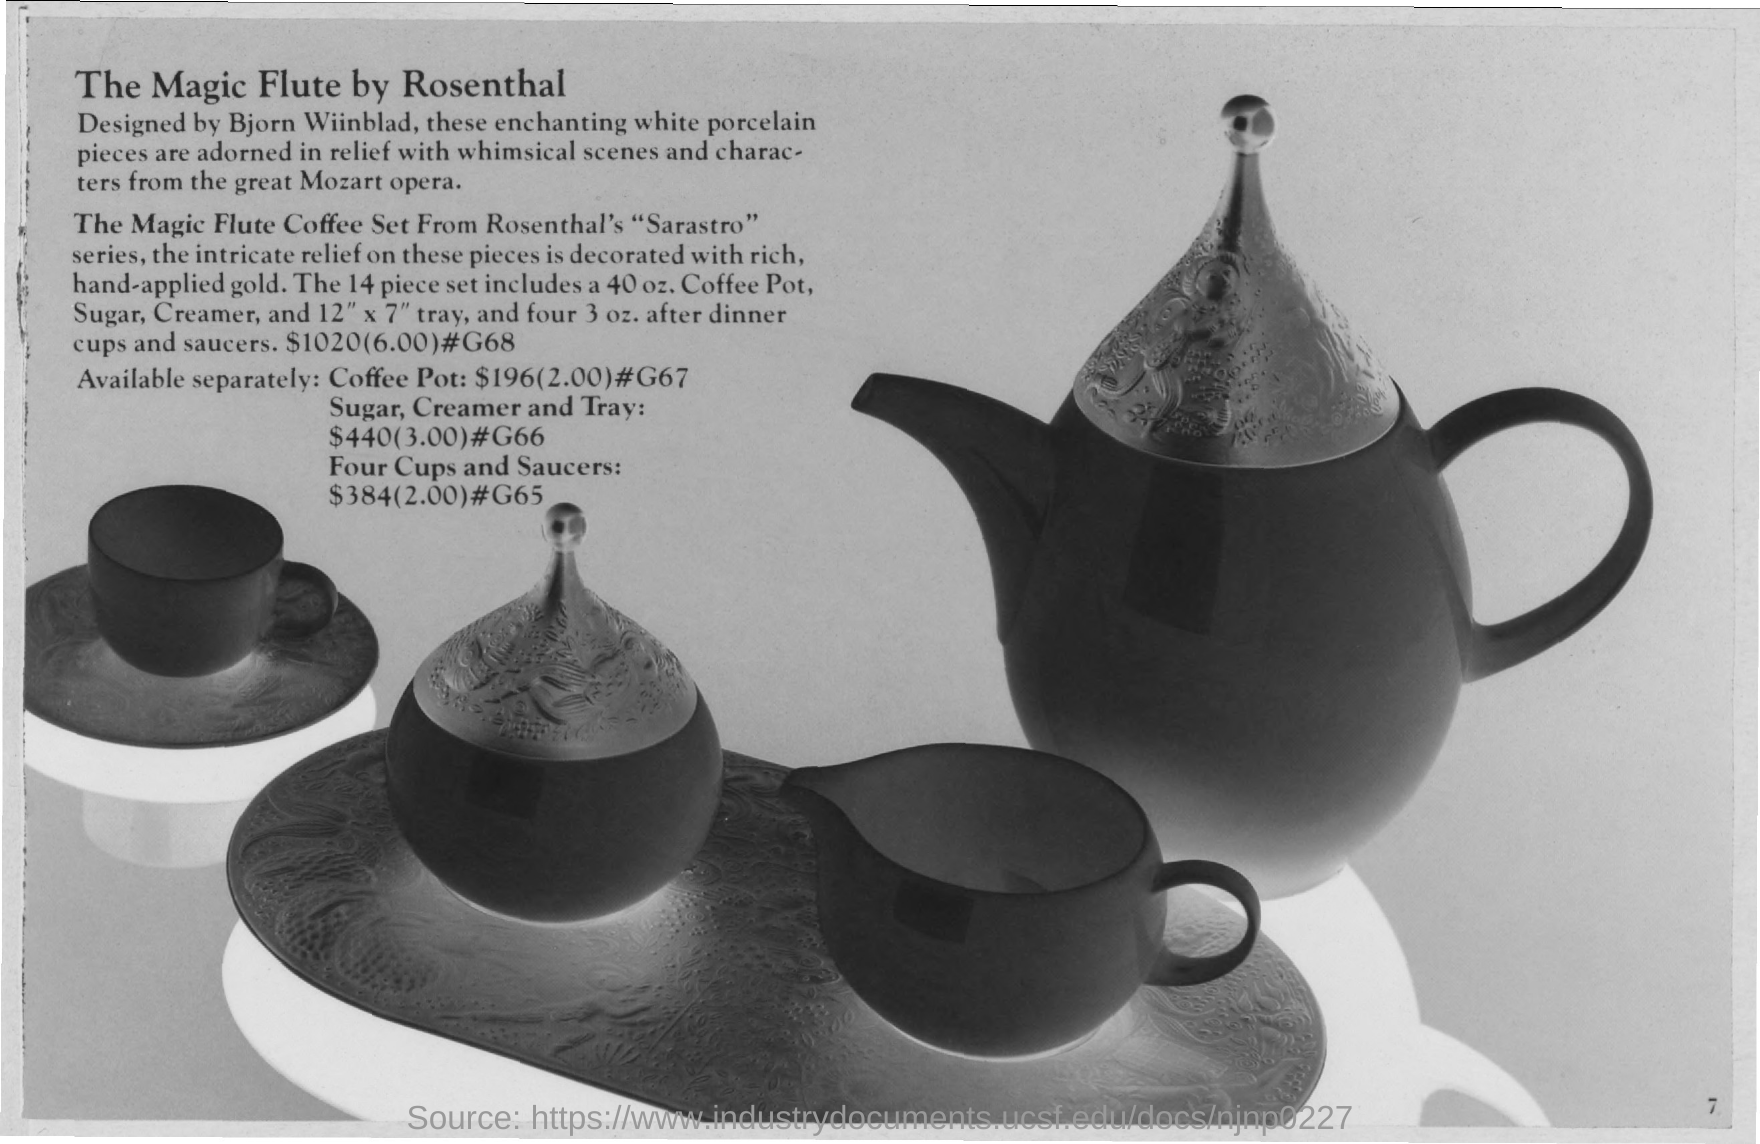Which series is the The Magic Flute Coffee Set from?
Provide a succinct answer. Sarastro. 